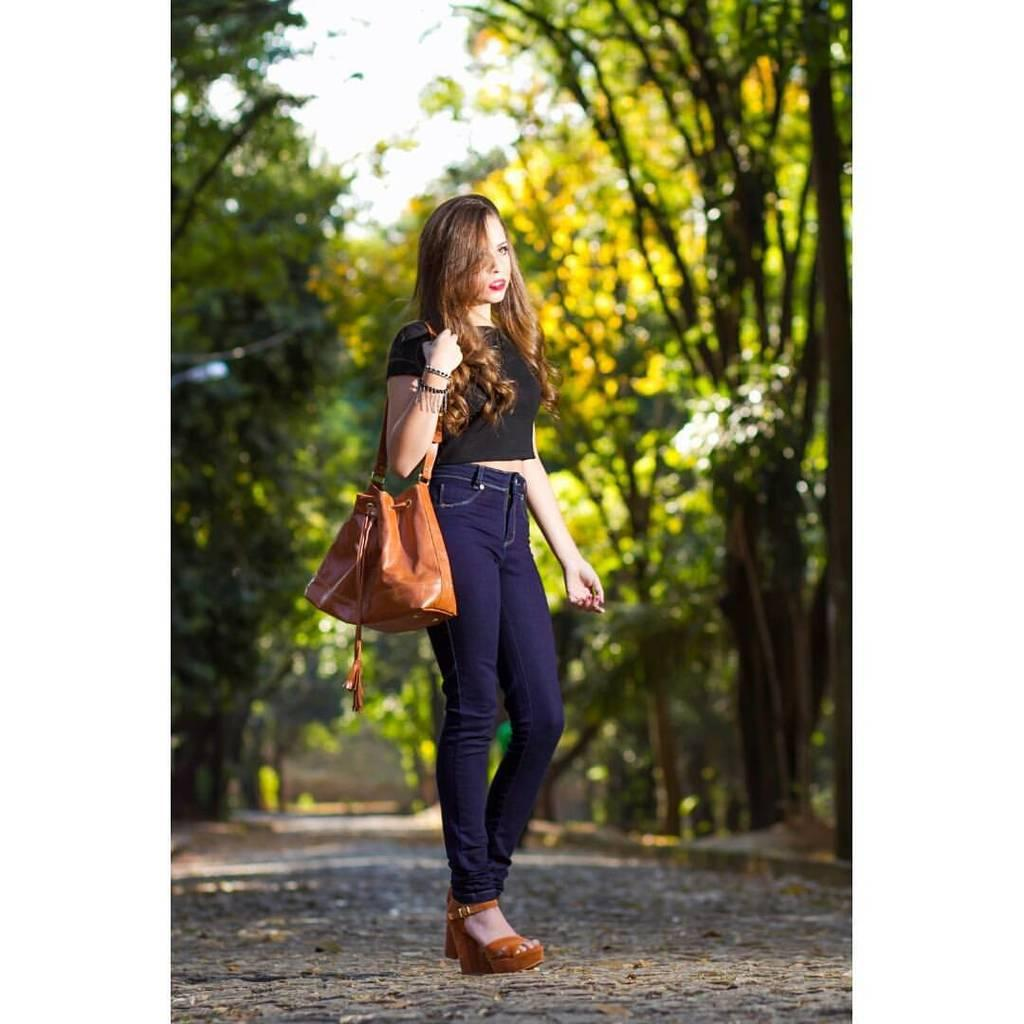What is the main subject of the image? The main subject of the image is a woman. What type of clothing is the woman wearing? The woman is wearing a t-shirt and trousers. Does the woman have any accessories in the image? Yes, the woman has a handbag. How is the woman's hair styled in the image? The woman has short hair. What can be seen in the background of the image? There are trees, sky, and a road visible in the background of the image. How many doors can be seen in the image? There are no doors visible in the image. What is the elbow of the woman doing in the image? The woman's elbow is not mentioned in the image, as the focus is on her clothing, accessories, and hairstyle. 